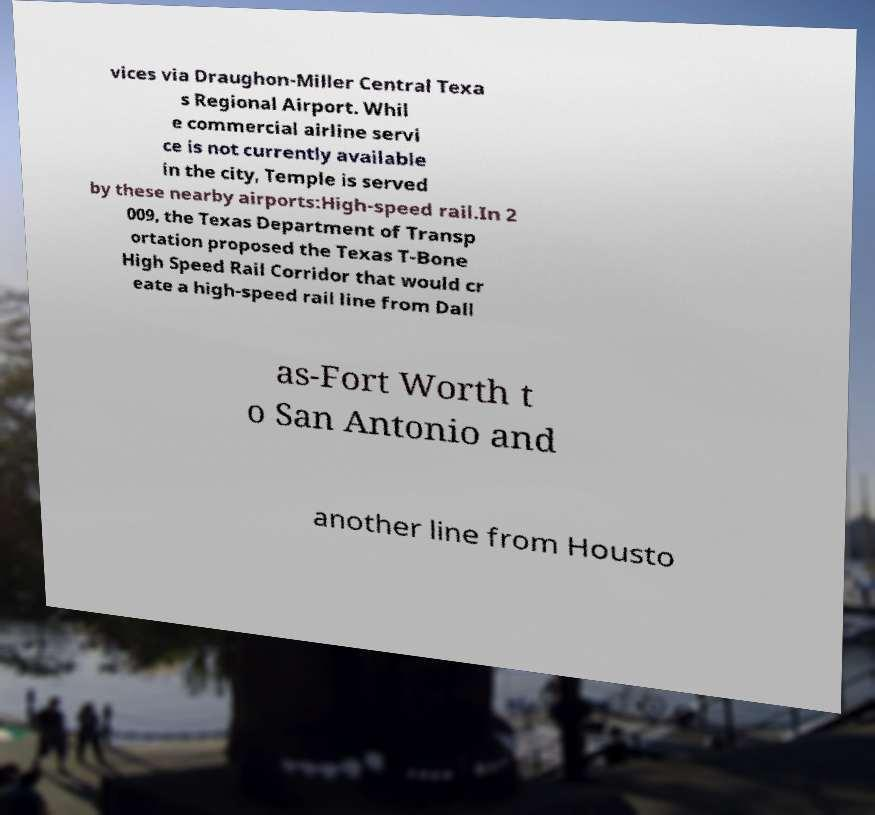Please read and relay the text visible in this image. What does it say? vices via Draughon-Miller Central Texa s Regional Airport. Whil e commercial airline servi ce is not currently available in the city, Temple is served by these nearby airports:High-speed rail.In 2 009, the Texas Department of Transp ortation proposed the Texas T-Bone High Speed Rail Corridor that would cr eate a high-speed rail line from Dall as-Fort Worth t o San Antonio and another line from Housto 